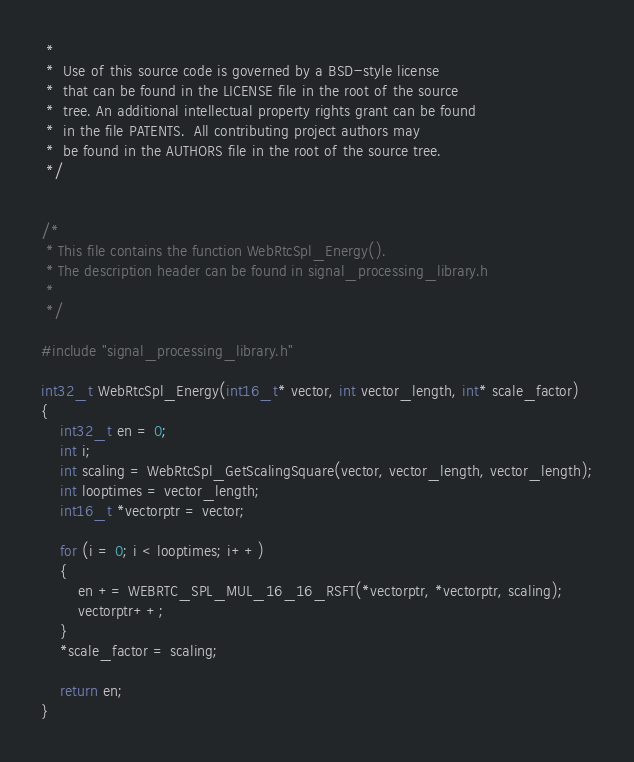<code> <loc_0><loc_0><loc_500><loc_500><_C_> *
 *  Use of this source code is governed by a BSD-style license
 *  that can be found in the LICENSE file in the root of the source
 *  tree. An additional intellectual property rights grant can be found
 *  in the file PATENTS.  All contributing project authors may
 *  be found in the AUTHORS file in the root of the source tree.
 */


/*
 * This file contains the function WebRtcSpl_Energy().
 * The description header can be found in signal_processing_library.h
 *
 */

#include "signal_processing_library.h"

int32_t WebRtcSpl_Energy(int16_t* vector, int vector_length, int* scale_factor)
{
    int32_t en = 0;
    int i;
    int scaling = WebRtcSpl_GetScalingSquare(vector, vector_length, vector_length);
    int looptimes = vector_length;
    int16_t *vectorptr = vector;

    for (i = 0; i < looptimes; i++)
    {
        en += WEBRTC_SPL_MUL_16_16_RSFT(*vectorptr, *vectorptr, scaling);
        vectorptr++;
    }
    *scale_factor = scaling;

    return en;
}
</code> 